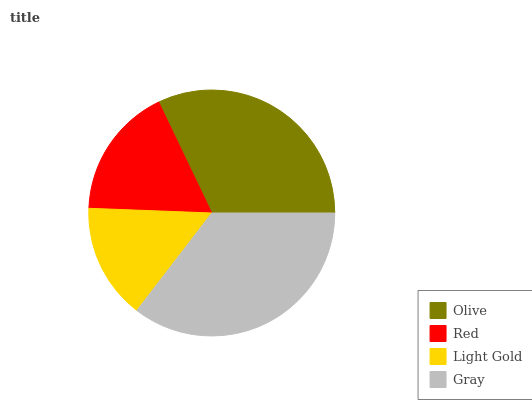Is Light Gold the minimum?
Answer yes or no. Yes. Is Gray the maximum?
Answer yes or no. Yes. Is Red the minimum?
Answer yes or no. No. Is Red the maximum?
Answer yes or no. No. Is Olive greater than Red?
Answer yes or no. Yes. Is Red less than Olive?
Answer yes or no. Yes. Is Red greater than Olive?
Answer yes or no. No. Is Olive less than Red?
Answer yes or no. No. Is Olive the high median?
Answer yes or no. Yes. Is Red the low median?
Answer yes or no. Yes. Is Light Gold the high median?
Answer yes or no. No. Is Olive the low median?
Answer yes or no. No. 